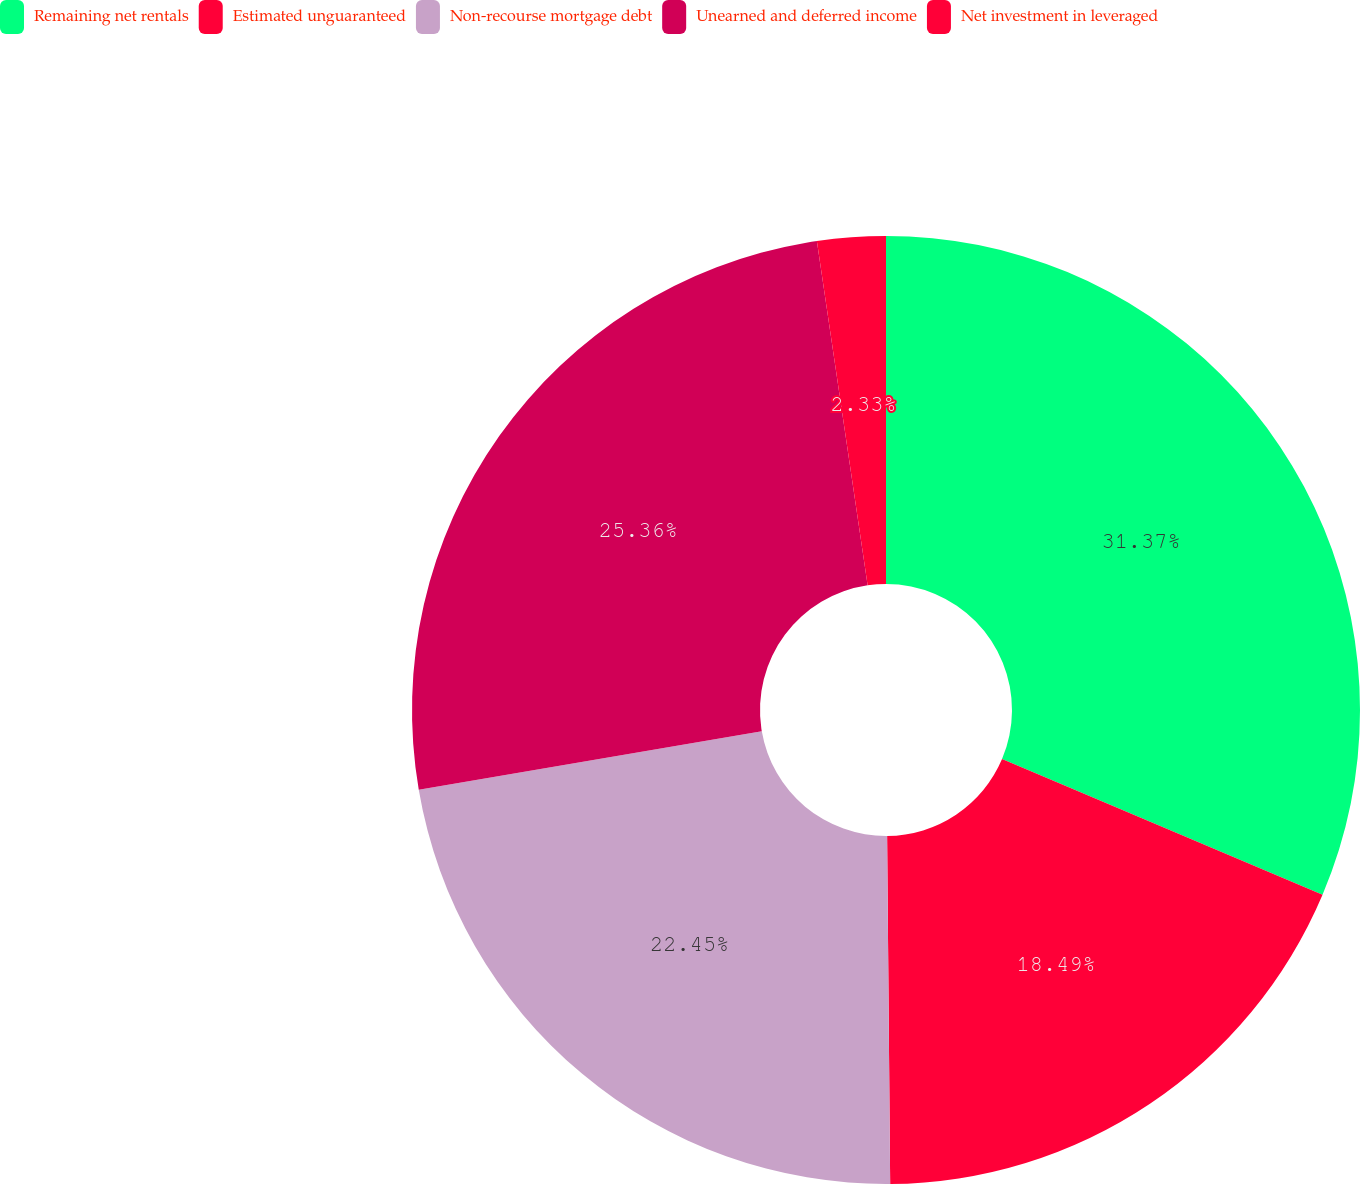<chart> <loc_0><loc_0><loc_500><loc_500><pie_chart><fcel>Remaining net rentals<fcel>Estimated unguaranteed<fcel>Non-recourse mortgage debt<fcel>Unearned and deferred income<fcel>Net investment in leveraged<nl><fcel>31.37%<fcel>18.49%<fcel>22.45%<fcel>25.36%<fcel>2.33%<nl></chart> 